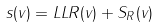<formula> <loc_0><loc_0><loc_500><loc_500>s ( v ) = L L R ( v ) + S _ { R } ( v )</formula> 